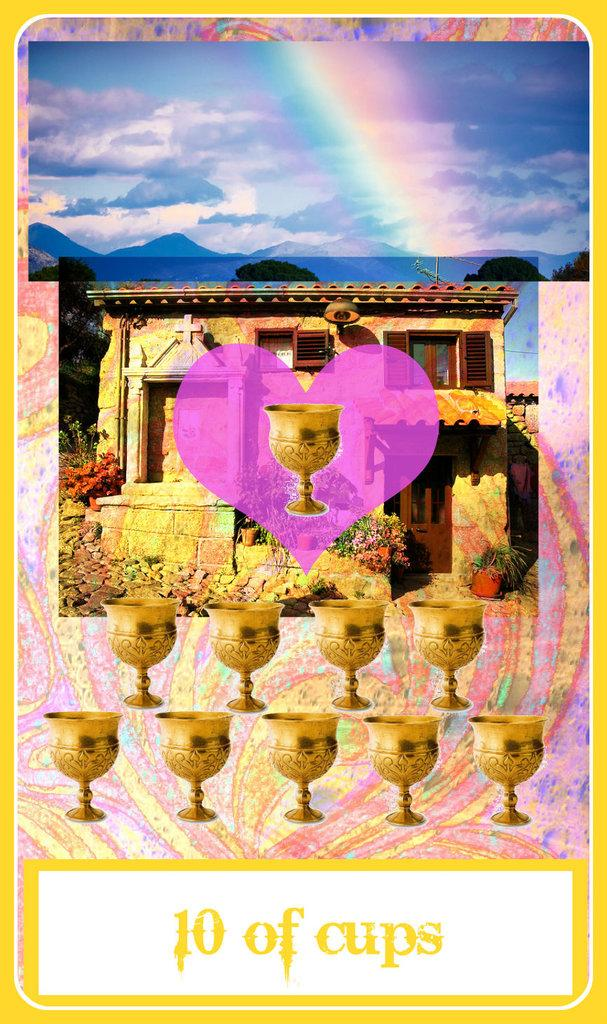<image>
Summarize the visual content of the image. A card with a house and rainbow and cups reading 10 of cups. 